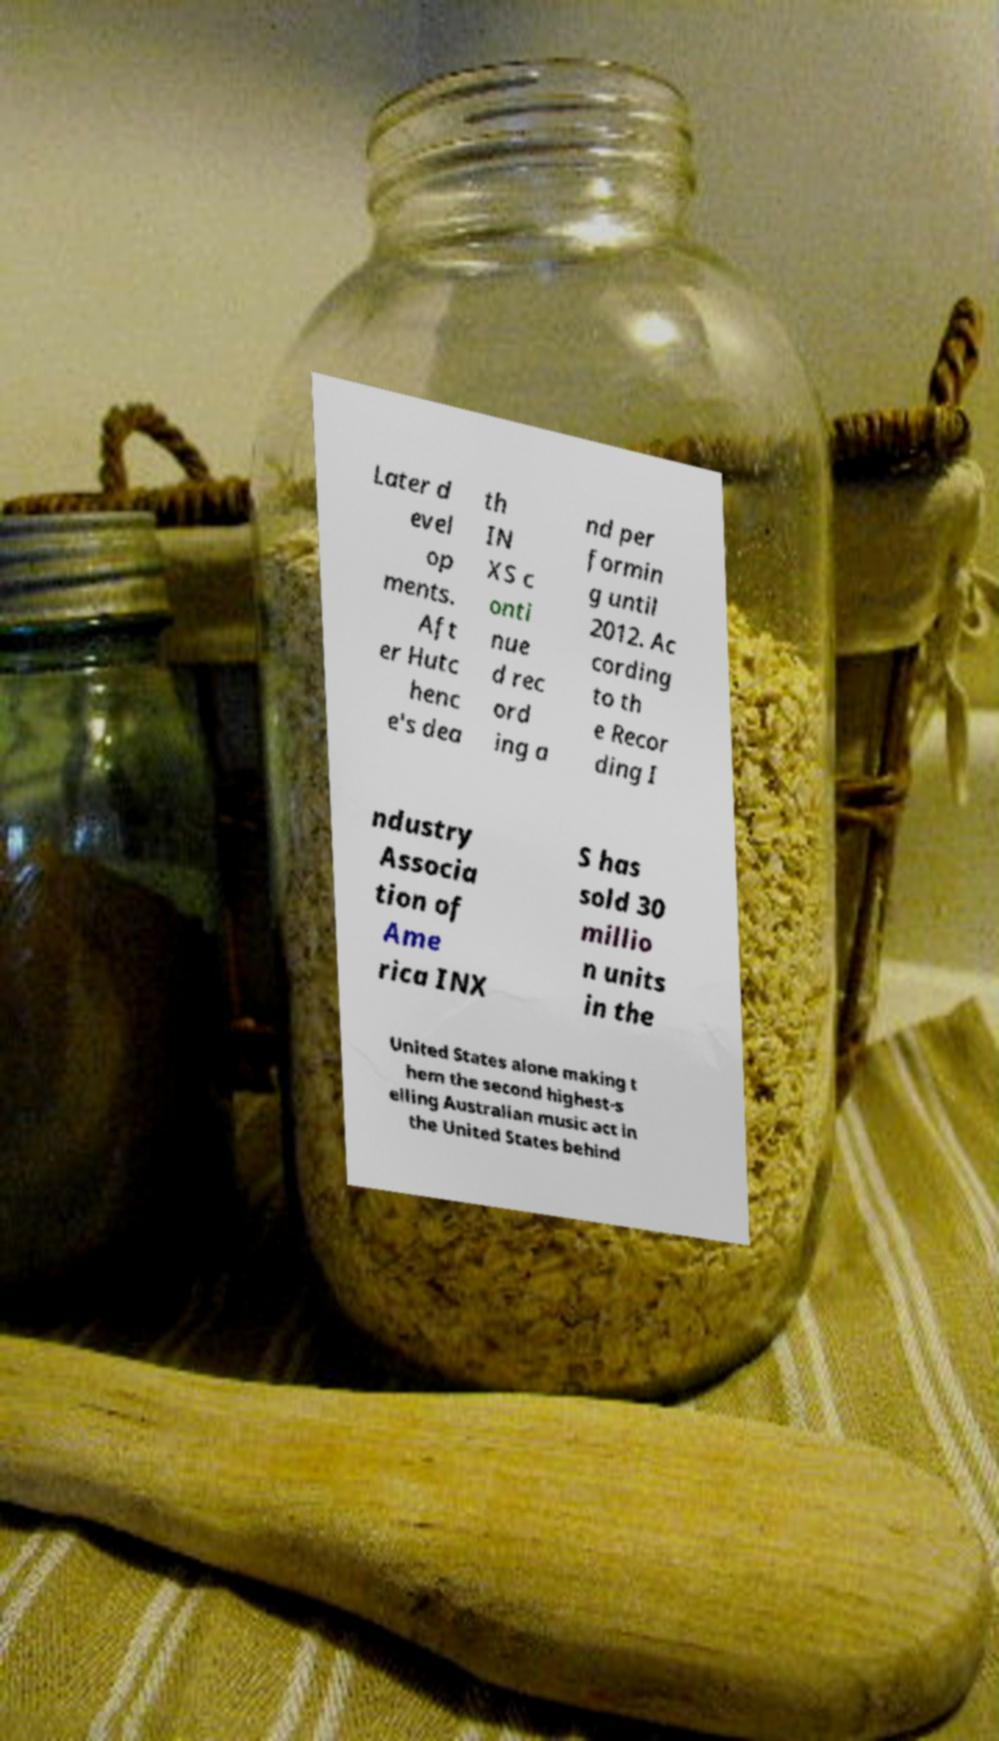Could you assist in decoding the text presented in this image and type it out clearly? Later d evel op ments. Aft er Hutc henc e's dea th IN XS c onti nue d rec ord ing a nd per formin g until 2012. Ac cording to th e Recor ding I ndustry Associa tion of Ame rica INX S has sold 30 millio n units in the United States alone making t hem the second highest-s elling Australian music act in the United States behind 